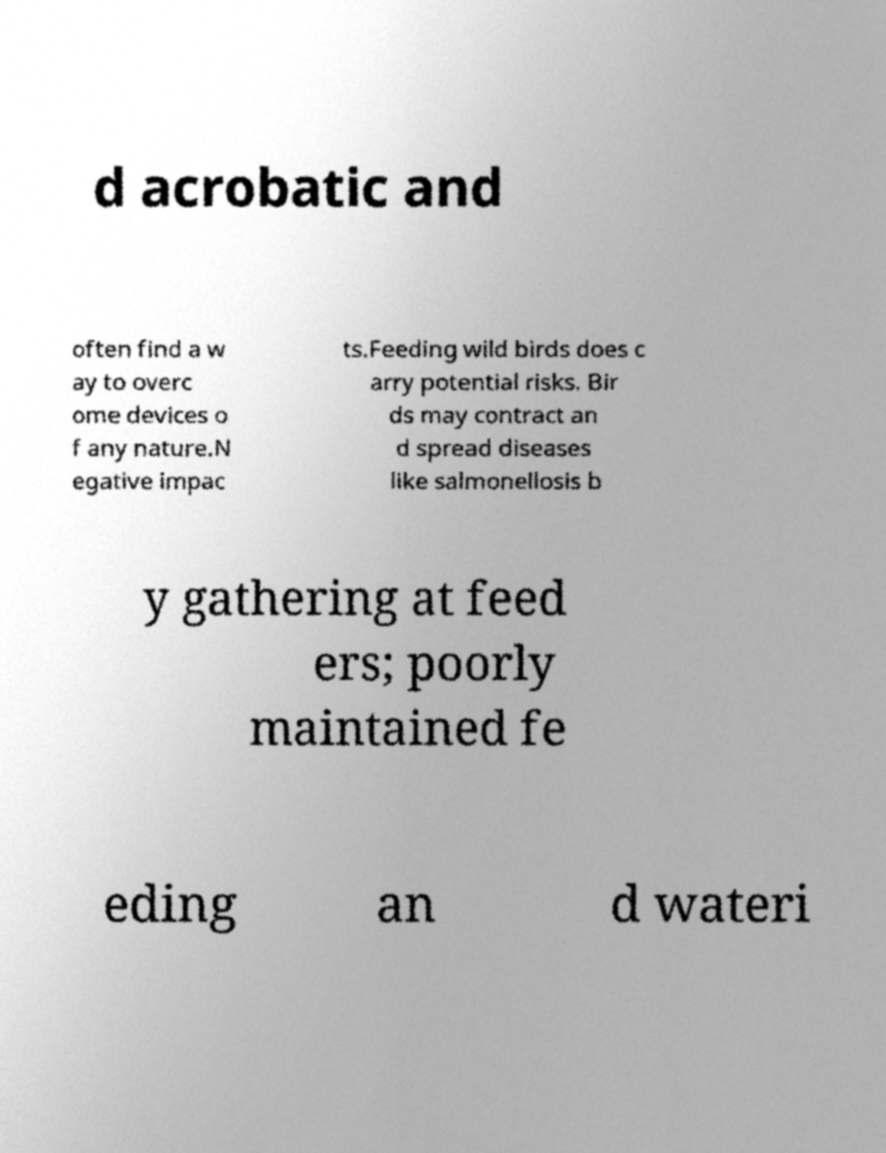I need the written content from this picture converted into text. Can you do that? d acrobatic and often find a w ay to overc ome devices o f any nature.N egative impac ts.Feeding wild birds does c arry potential risks. Bir ds may contract an d spread diseases like salmonellosis b y gathering at feed ers; poorly maintained fe eding an d wateri 